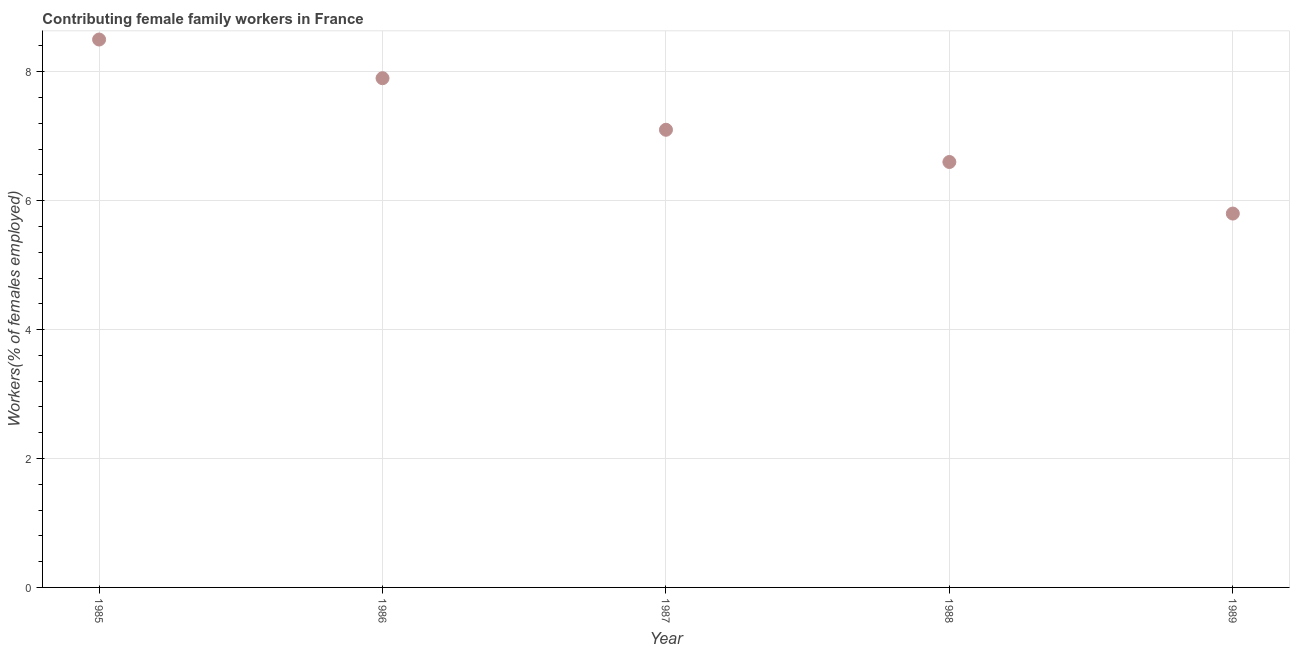What is the contributing female family workers in 1988?
Your response must be concise. 6.6. Across all years, what is the minimum contributing female family workers?
Offer a very short reply. 5.8. In which year was the contributing female family workers maximum?
Keep it short and to the point. 1985. In which year was the contributing female family workers minimum?
Make the answer very short. 1989. What is the sum of the contributing female family workers?
Your response must be concise. 35.9. What is the difference between the contributing female family workers in 1986 and 1987?
Provide a short and direct response. 0.8. What is the average contributing female family workers per year?
Offer a very short reply. 7.18. What is the median contributing female family workers?
Your response must be concise. 7.1. In how many years, is the contributing female family workers greater than 7.2 %?
Provide a succinct answer. 2. Do a majority of the years between 1985 and 1989 (inclusive) have contributing female family workers greater than 0.8 %?
Offer a very short reply. Yes. What is the ratio of the contributing female family workers in 1987 to that in 1988?
Provide a short and direct response. 1.08. Is the contributing female family workers in 1987 less than that in 1988?
Ensure brevity in your answer.  No. Is the difference between the contributing female family workers in 1985 and 1989 greater than the difference between any two years?
Your answer should be compact. Yes. What is the difference between the highest and the second highest contributing female family workers?
Provide a short and direct response. 0.6. What is the difference between the highest and the lowest contributing female family workers?
Provide a short and direct response. 2.7. In how many years, is the contributing female family workers greater than the average contributing female family workers taken over all years?
Offer a very short reply. 2. Does the contributing female family workers monotonically increase over the years?
Offer a very short reply. No. How many dotlines are there?
Offer a terse response. 1. What is the difference between two consecutive major ticks on the Y-axis?
Your answer should be compact. 2. What is the title of the graph?
Make the answer very short. Contributing female family workers in France. What is the label or title of the Y-axis?
Provide a short and direct response. Workers(% of females employed). What is the Workers(% of females employed) in 1985?
Keep it short and to the point. 8.5. What is the Workers(% of females employed) in 1986?
Make the answer very short. 7.9. What is the Workers(% of females employed) in 1987?
Your answer should be compact. 7.1. What is the Workers(% of females employed) in 1988?
Make the answer very short. 6.6. What is the Workers(% of females employed) in 1989?
Provide a succinct answer. 5.8. What is the difference between the Workers(% of females employed) in 1985 and 1986?
Offer a terse response. 0.6. What is the difference between the Workers(% of females employed) in 1985 and 1987?
Give a very brief answer. 1.4. What is the difference between the Workers(% of females employed) in 1985 and 1989?
Provide a short and direct response. 2.7. What is the difference between the Workers(% of females employed) in 1986 and 1987?
Keep it short and to the point. 0.8. What is the difference between the Workers(% of females employed) in 1987 and 1988?
Your answer should be compact. 0.5. What is the ratio of the Workers(% of females employed) in 1985 to that in 1986?
Provide a succinct answer. 1.08. What is the ratio of the Workers(% of females employed) in 1985 to that in 1987?
Offer a terse response. 1.2. What is the ratio of the Workers(% of females employed) in 1985 to that in 1988?
Provide a short and direct response. 1.29. What is the ratio of the Workers(% of females employed) in 1985 to that in 1989?
Offer a very short reply. 1.47. What is the ratio of the Workers(% of females employed) in 1986 to that in 1987?
Provide a short and direct response. 1.11. What is the ratio of the Workers(% of females employed) in 1986 to that in 1988?
Give a very brief answer. 1.2. What is the ratio of the Workers(% of females employed) in 1986 to that in 1989?
Ensure brevity in your answer.  1.36. What is the ratio of the Workers(% of females employed) in 1987 to that in 1988?
Give a very brief answer. 1.08. What is the ratio of the Workers(% of females employed) in 1987 to that in 1989?
Make the answer very short. 1.22. What is the ratio of the Workers(% of females employed) in 1988 to that in 1989?
Provide a succinct answer. 1.14. 